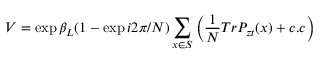Convert formula to latex. <formula><loc_0><loc_0><loc_500><loc_500>V = \exp { \beta _ { L } ( 1 - \exp { i 2 \pi / N } ) \sum _ { x \in S } \left ( { \frac { 1 } { N } } T r P _ { z t } ( x ) + c . c \right ) }</formula> 